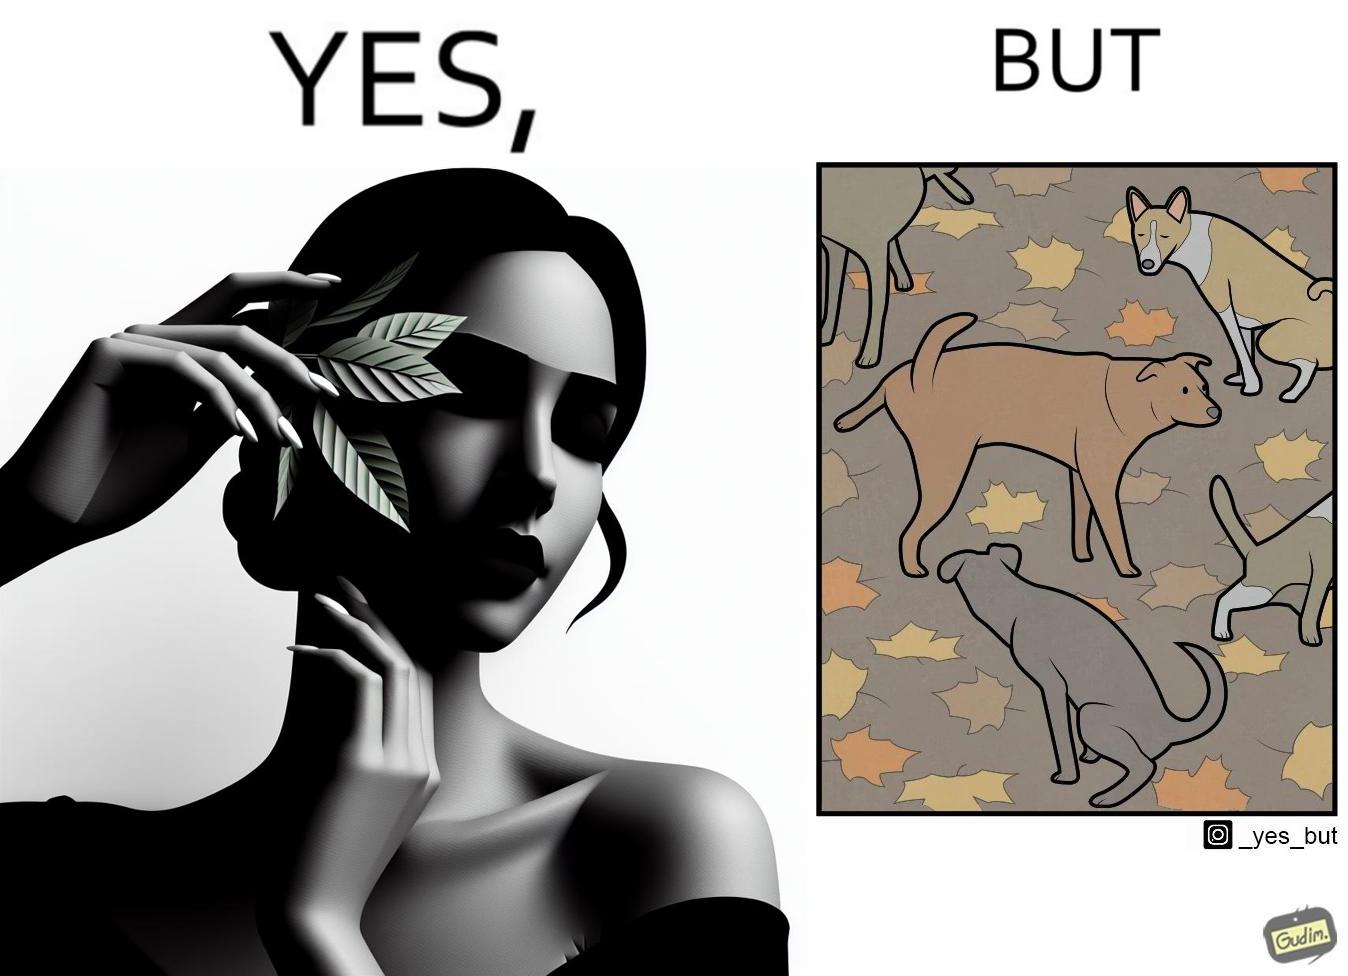Describe the content of this image. The images are funny since it show a woman holding a leaf over half of her face for a good photo but unknown to her is thale fact the same leaf might have been defecated or urinated upon by dogs and other wild animals 